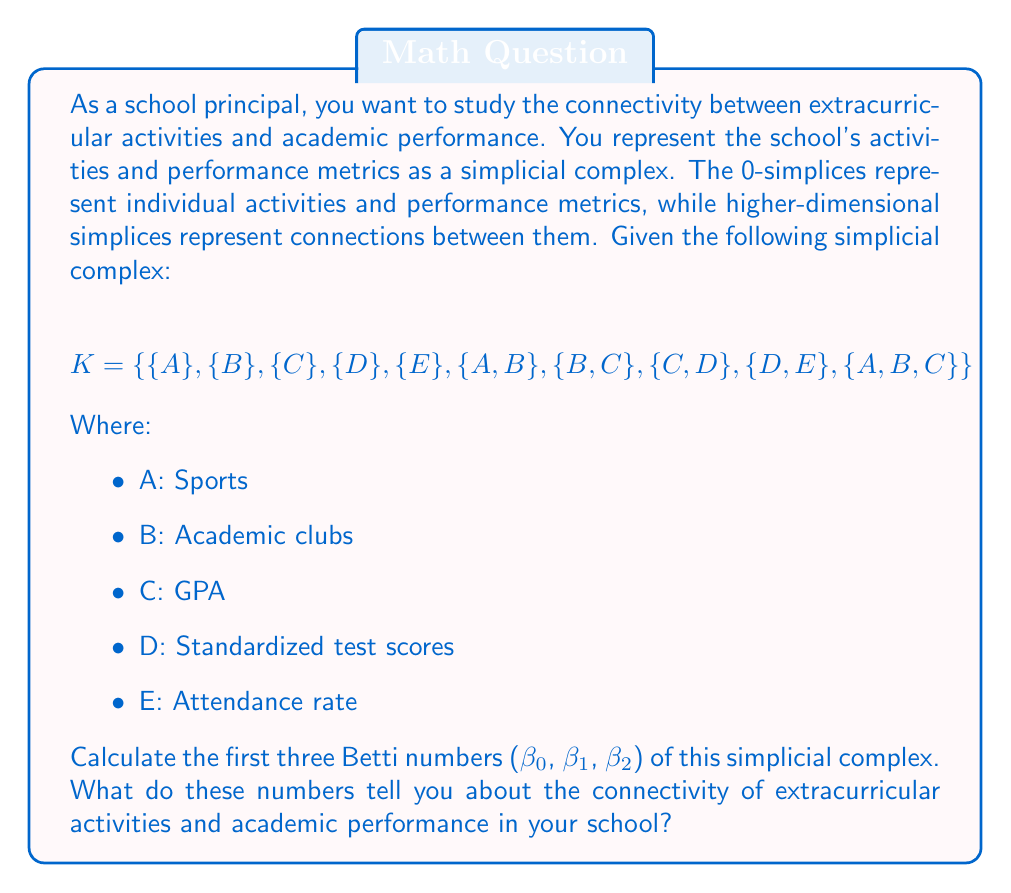Solve this math problem. To calculate the Betti numbers, we need to determine the ranks of the boundary maps and the dimensions of the chain groups. Let's go through this step-by-step:

1. First, let's identify the simplices in each dimension:
   - 0-simplices: $\{A\}, \{B\}, \{C\}, \{D\}, \{E\}$
   - 1-simplices: $\{A,B\}, \{B,C\}, \{C,D\}, \{D,E\}$
   - 2-simplices: $\{A,B,C\}$

2. Now, let's calculate the dimensions of the chain groups:
   - $dim C_0 = 5$ (number of 0-simplices)
   - $dim C_1 = 4$ (number of 1-simplices)
   - $dim C_2 = 1$ (number of 2-simplices)
   - $dim C_3 = 0$ (no 3-simplices)

3. Next, we need to calculate the ranks of the boundary maps:
   - $rank \partial_1 = 3$ (number of connected components minus 1)
   - $rank \partial_2 = 1$ (rank of the matrix representing the boundary map from 2-simplices to 1-simplices)
   - $rank \partial_3 = 0$ (no 3-simplices, so the rank is 0)

4. Now we can calculate the Betti numbers using the formula:
   $\beta_k = dim ker \partial_k - rank \partial_{k+1}$

   For $\beta_0$:
   $\beta_0 = dim ker \partial_0 - rank \partial_1 = dim C_0 - rank \partial_1 = 5 - 3 = 2$

   For $\beta_1$:
   $\beta_1 = dim ker \partial_1 - rank \partial_2 = (dim C_1 - rank \partial_1) - rank \partial_2 = (4 - 3) - 1 = 0$

   For $\beta_2$:
   $\beta_2 = dim ker \partial_2 - rank \partial_3 = (dim C_2 - rank \partial_2) - rank \partial_3 = (1 - 1) - 0 = 0$

5. Interpretation of the Betti numbers:
   - $\beta_0 = 2$: This indicates that there are 2 connected components in the simplicial complex. It suggests that there are two distinct groups of activities and performance metrics that are not directly connected.
   - $\beta_1 = 0$: This means there are no 1-dimensional holes or loops in the complex. All 1-dimensional connections form a tree-like structure without cycles.
   - $\beta_2 = 0$: There are no 2-dimensional voids or cavities in the complex.

These Betti numbers suggest that while there are some connections between extracurricular activities and academic performance metrics, the overall structure is not fully connected. There are two separate groups, which might indicate a need for better integration between certain activities and performance measures.
Answer: The Betti numbers are:
$\beta_0 = 2$
$\beta_1 = 0$
$\beta_2 = 0$

These numbers indicate that there are two distinct connected components in the relationship between extracurricular activities and academic performance, no loops or cycles in the connections, and no higher-dimensional voids. 